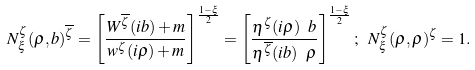Convert formula to latex. <formula><loc_0><loc_0><loc_500><loc_500>N ^ { \zeta } _ { \xi } ( \varrho , b ) ^ { \overline { \zeta } } = \left [ \frac { W ^ { \overline { \zeta } } ( i b ) + m } { w ^ { \zeta } ( i \varrho ) + m } \right ] ^ { \frac { 1 - \xi } { 2 } } = \left [ \frac { \eta ^ { \zeta } ( i \varrho ) \ b } { \eta ^ { \overline { \zeta } } ( i b ) \ \varrho } \right ] ^ { \frac { 1 - \xi } { 2 } } ; \ N ^ { \zeta } _ { \xi } ( \varrho , \varrho ) ^ { \zeta } = 1 .</formula> 